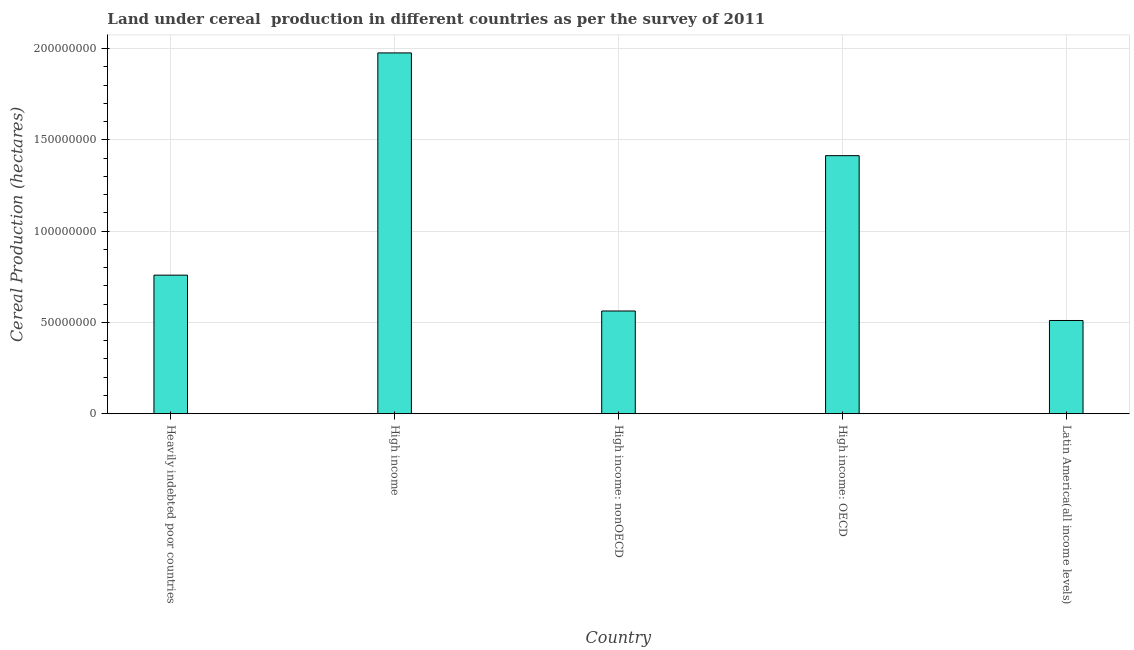Does the graph contain grids?
Ensure brevity in your answer.  Yes. What is the title of the graph?
Ensure brevity in your answer.  Land under cereal  production in different countries as per the survey of 2011. What is the label or title of the X-axis?
Provide a succinct answer. Country. What is the label or title of the Y-axis?
Offer a terse response. Cereal Production (hectares). What is the land under cereal production in High income: nonOECD?
Provide a succinct answer. 5.63e+07. Across all countries, what is the maximum land under cereal production?
Ensure brevity in your answer.  1.98e+08. Across all countries, what is the minimum land under cereal production?
Your answer should be very brief. 5.11e+07. In which country was the land under cereal production maximum?
Provide a short and direct response. High income. In which country was the land under cereal production minimum?
Your response must be concise. Latin America(all income levels). What is the sum of the land under cereal production?
Provide a succinct answer. 5.22e+08. What is the difference between the land under cereal production in Heavily indebted poor countries and High income?
Offer a terse response. -1.22e+08. What is the average land under cereal production per country?
Make the answer very short. 1.04e+08. What is the median land under cereal production?
Your response must be concise. 7.59e+07. What is the ratio of the land under cereal production in High income to that in High income: nonOECD?
Your answer should be compact. 3.51. Is the land under cereal production in Heavily indebted poor countries less than that in Latin America(all income levels)?
Provide a short and direct response. No. What is the difference between the highest and the second highest land under cereal production?
Your answer should be compact. 5.63e+07. What is the difference between the highest and the lowest land under cereal production?
Give a very brief answer. 1.47e+08. How many bars are there?
Your response must be concise. 5. How many countries are there in the graph?
Offer a very short reply. 5. What is the Cereal Production (hectares) in Heavily indebted poor countries?
Ensure brevity in your answer.  7.59e+07. What is the Cereal Production (hectares) in High income?
Keep it short and to the point. 1.98e+08. What is the Cereal Production (hectares) of High income: nonOECD?
Provide a short and direct response. 5.63e+07. What is the Cereal Production (hectares) of High income: OECD?
Give a very brief answer. 1.41e+08. What is the Cereal Production (hectares) in Latin America(all income levels)?
Your response must be concise. 5.11e+07. What is the difference between the Cereal Production (hectares) in Heavily indebted poor countries and High income?
Offer a terse response. -1.22e+08. What is the difference between the Cereal Production (hectares) in Heavily indebted poor countries and High income: nonOECD?
Offer a terse response. 1.96e+07. What is the difference between the Cereal Production (hectares) in Heavily indebted poor countries and High income: OECD?
Offer a very short reply. -6.54e+07. What is the difference between the Cereal Production (hectares) in Heavily indebted poor countries and Latin America(all income levels)?
Give a very brief answer. 2.48e+07. What is the difference between the Cereal Production (hectares) in High income and High income: nonOECD?
Provide a short and direct response. 1.41e+08. What is the difference between the Cereal Production (hectares) in High income and High income: OECD?
Provide a short and direct response. 5.63e+07. What is the difference between the Cereal Production (hectares) in High income and Latin America(all income levels)?
Ensure brevity in your answer.  1.47e+08. What is the difference between the Cereal Production (hectares) in High income: nonOECD and High income: OECD?
Make the answer very short. -8.51e+07. What is the difference between the Cereal Production (hectares) in High income: nonOECD and Latin America(all income levels)?
Your response must be concise. 5.20e+06. What is the difference between the Cereal Production (hectares) in High income: OECD and Latin America(all income levels)?
Your answer should be very brief. 9.03e+07. What is the ratio of the Cereal Production (hectares) in Heavily indebted poor countries to that in High income?
Your response must be concise. 0.38. What is the ratio of the Cereal Production (hectares) in Heavily indebted poor countries to that in High income: nonOECD?
Give a very brief answer. 1.35. What is the ratio of the Cereal Production (hectares) in Heavily indebted poor countries to that in High income: OECD?
Make the answer very short. 0.54. What is the ratio of the Cereal Production (hectares) in Heavily indebted poor countries to that in Latin America(all income levels)?
Provide a succinct answer. 1.49. What is the ratio of the Cereal Production (hectares) in High income to that in High income: nonOECD?
Provide a short and direct response. 3.51. What is the ratio of the Cereal Production (hectares) in High income to that in High income: OECD?
Ensure brevity in your answer.  1.4. What is the ratio of the Cereal Production (hectares) in High income to that in Latin America(all income levels)?
Keep it short and to the point. 3.87. What is the ratio of the Cereal Production (hectares) in High income: nonOECD to that in High income: OECD?
Ensure brevity in your answer.  0.4. What is the ratio of the Cereal Production (hectares) in High income: nonOECD to that in Latin America(all income levels)?
Your response must be concise. 1.1. What is the ratio of the Cereal Production (hectares) in High income: OECD to that in Latin America(all income levels)?
Your answer should be compact. 2.77. 